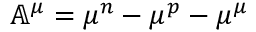Convert formula to latex. <formula><loc_0><loc_0><loc_500><loc_500>\mathbb { A } ^ { \mu } = \mu ^ { n } - \mu ^ { p } - \mu ^ { \mu }</formula> 